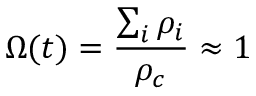Convert formula to latex. <formula><loc_0><loc_0><loc_500><loc_500>\Omega ( t ) = \frac { \sum _ { i } \rho _ { i } } { \rho _ { c } } \approx 1</formula> 